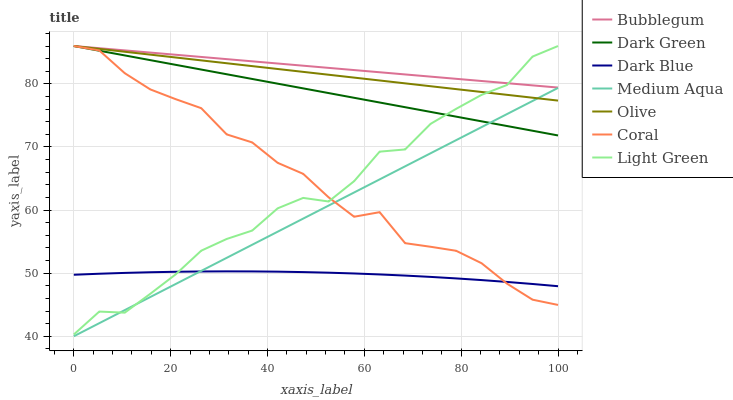Does Dark Blue have the minimum area under the curve?
Answer yes or no. Yes. Does Bubblegum have the maximum area under the curve?
Answer yes or no. Yes. Does Bubblegum have the minimum area under the curve?
Answer yes or no. No. Does Dark Blue have the maximum area under the curve?
Answer yes or no. No. Is Bubblegum the smoothest?
Answer yes or no. Yes. Is Light Green the roughest?
Answer yes or no. Yes. Is Dark Blue the smoothest?
Answer yes or no. No. Is Dark Blue the roughest?
Answer yes or no. No. Does Medium Aqua have the lowest value?
Answer yes or no. Yes. Does Dark Blue have the lowest value?
Answer yes or no. No. Does Dark Green have the highest value?
Answer yes or no. Yes. Does Dark Blue have the highest value?
Answer yes or no. No. Is Dark Blue less than Bubblegum?
Answer yes or no. Yes. Is Bubblegum greater than Medium Aqua?
Answer yes or no. Yes. Does Medium Aqua intersect Coral?
Answer yes or no. Yes. Is Medium Aqua less than Coral?
Answer yes or no. No. Is Medium Aqua greater than Coral?
Answer yes or no. No. Does Dark Blue intersect Bubblegum?
Answer yes or no. No. 